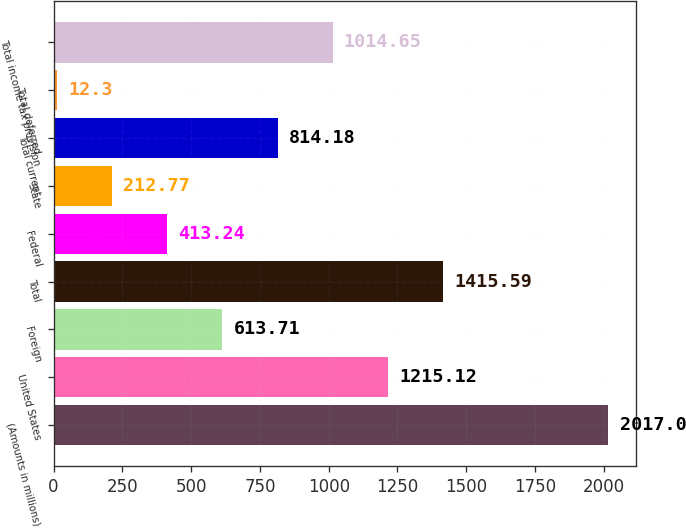<chart> <loc_0><loc_0><loc_500><loc_500><bar_chart><fcel>(Amounts in millions)<fcel>United States<fcel>Foreign<fcel>Total<fcel>Federal<fcel>State<fcel>Total current<fcel>Total deferred<fcel>Total income tax provision<nl><fcel>2017<fcel>1215.12<fcel>613.71<fcel>1415.59<fcel>413.24<fcel>212.77<fcel>814.18<fcel>12.3<fcel>1014.65<nl></chart> 